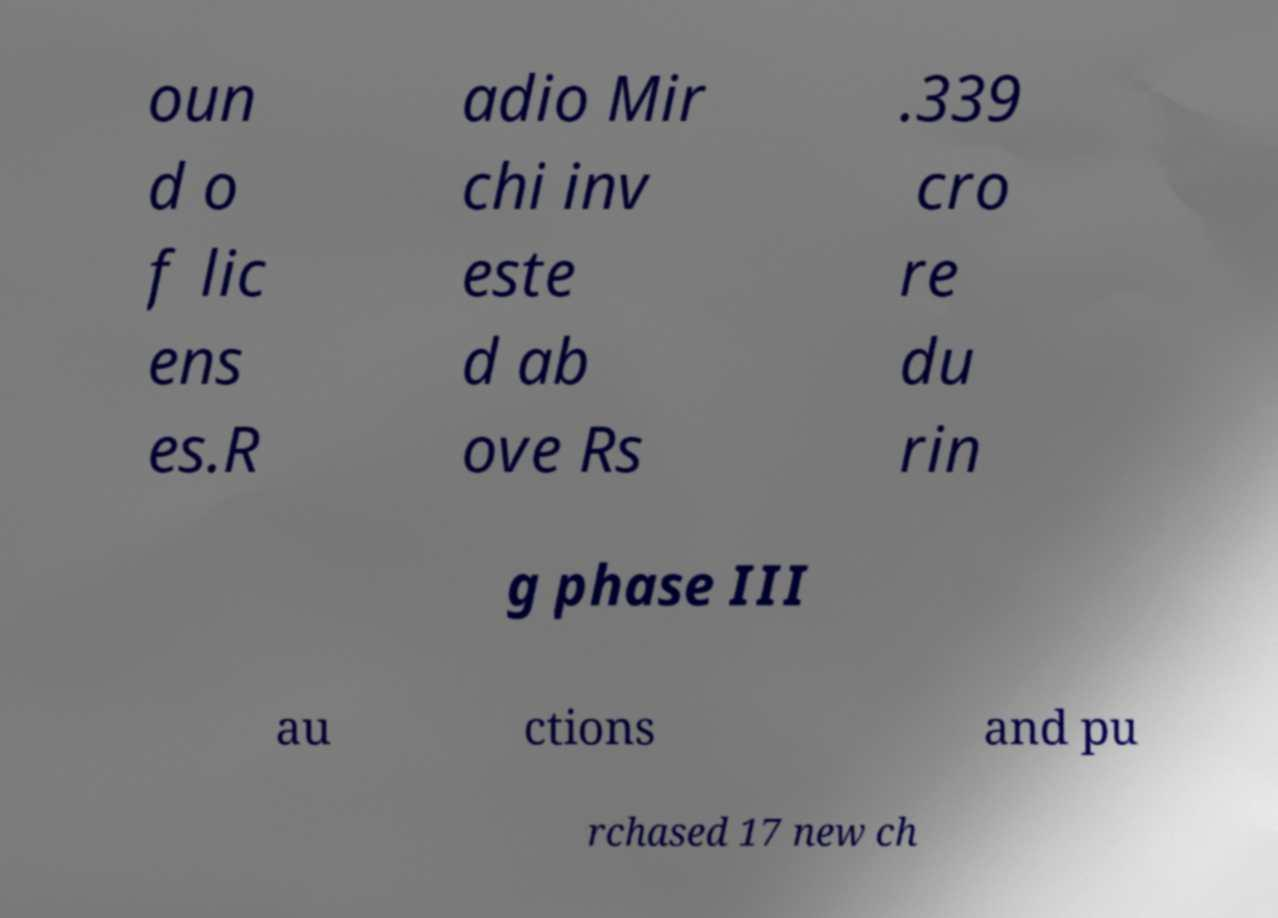There's text embedded in this image that I need extracted. Can you transcribe it verbatim? oun d o f lic ens es.R adio Mir chi inv este d ab ove Rs .339 cro re du rin g phase III au ctions and pu rchased 17 new ch 